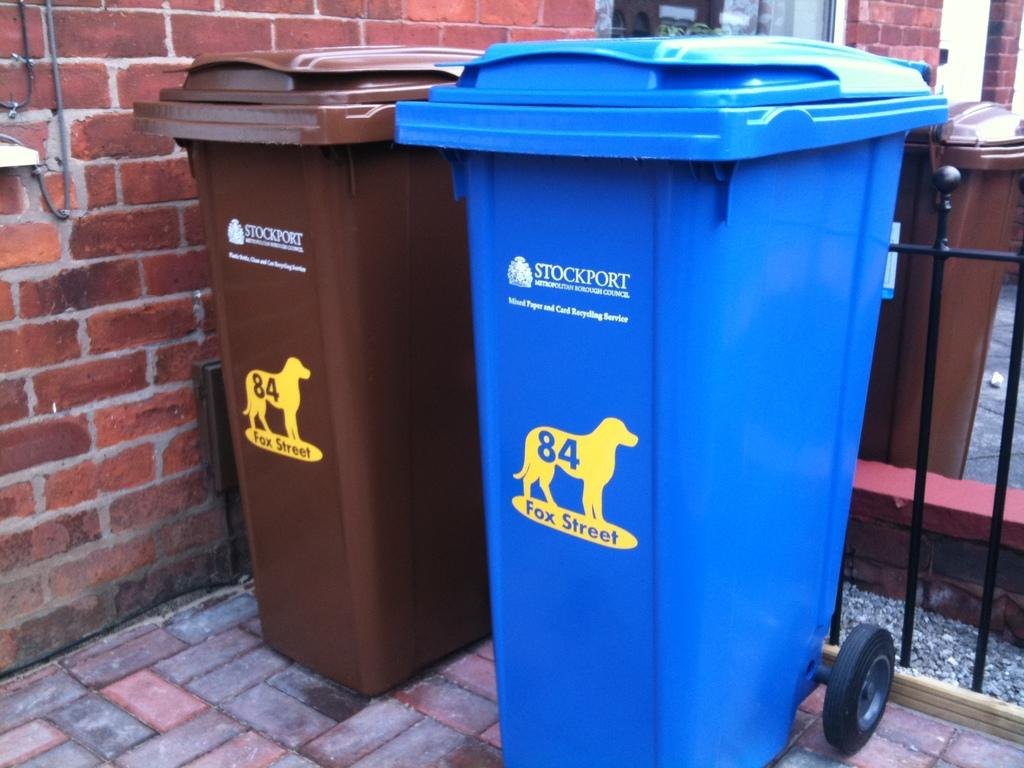Provide a one-sentence caption for the provided image. two trash cans, one blue one brown, with a 84 fox street decal. 